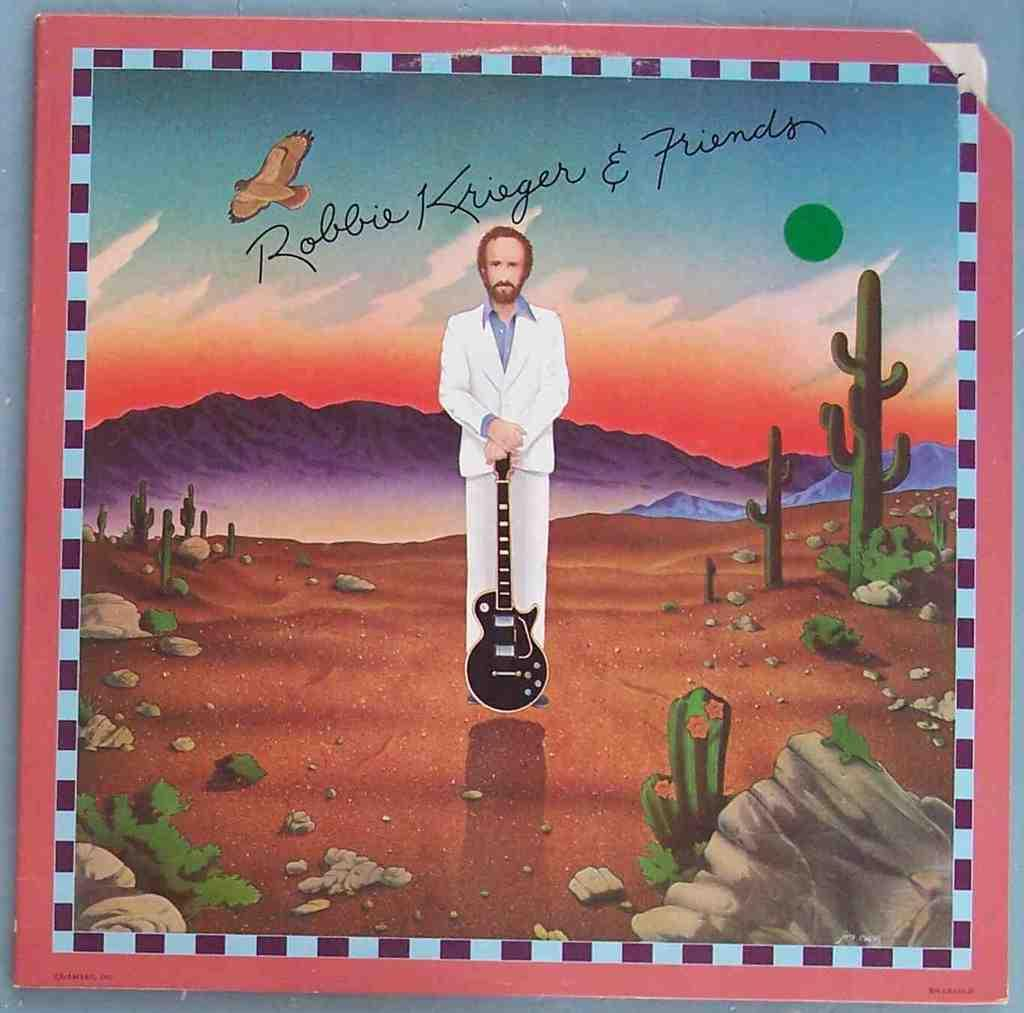<image>
Relay a brief, clear account of the picture shown. An album cover says Robbie Krieger and Friends. 